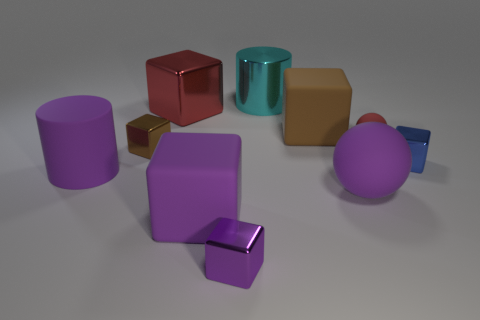Subtract all brown metal cubes. How many cubes are left? 5 Subtract all blue cylinders. How many purple cubes are left? 2 Subtract all spheres. How many objects are left? 8 Subtract all purple cylinders. How many cylinders are left? 1 Subtract all big green metallic spheres. Subtract all blue shiny cubes. How many objects are left? 9 Add 4 small purple blocks. How many small purple blocks are left? 5 Add 7 tiny blue blocks. How many tiny blue blocks exist? 8 Subtract 1 red cubes. How many objects are left? 9 Subtract all brown balls. Subtract all gray cylinders. How many balls are left? 2 